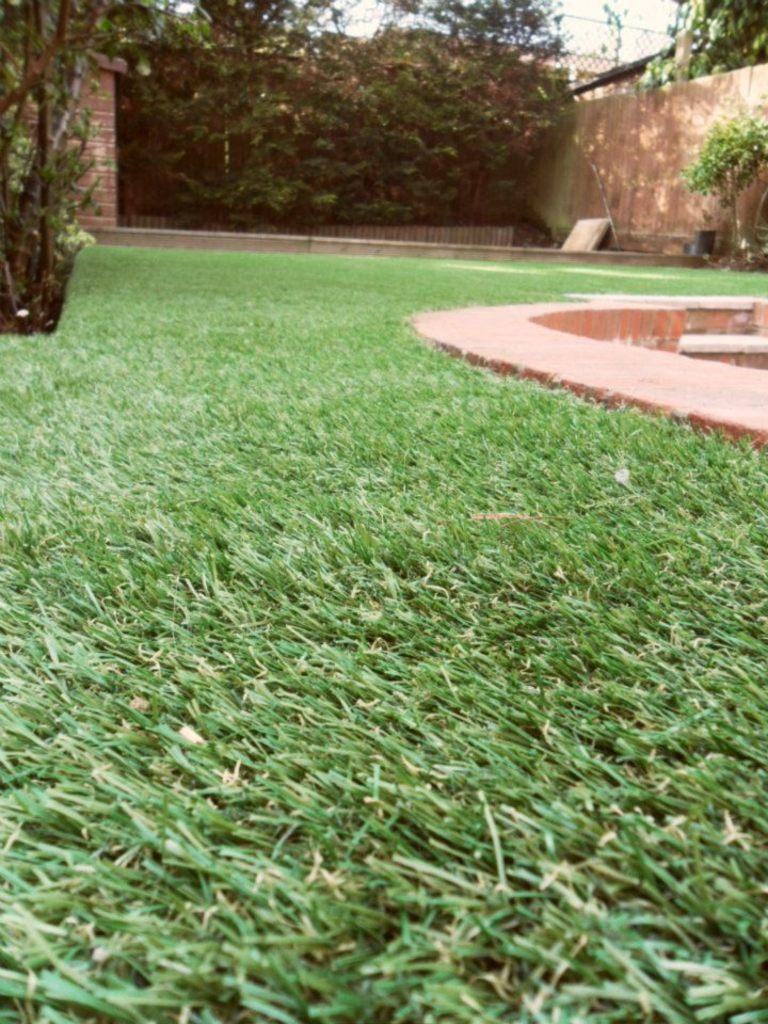What type of vegetation can be seen in the image? There is grass and trees in the image. What architectural features are present in the image? There is a wall, steps, and a fence in the image. What part of the natural environment is visible in the image? The sky is visible in the background of the image. What type of ticket is visible in the image? There is no ticket present in the image. What color is the skirt worn by the tree in the image? Trees do not wear skirts, and there is no clothing item present in the image. 